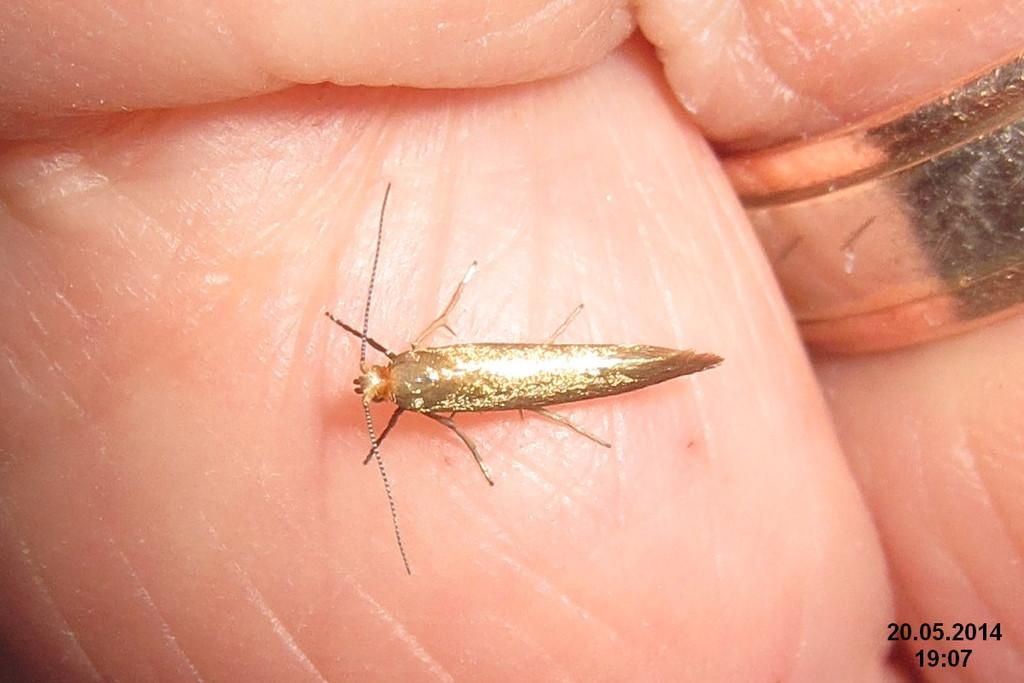What is present on the skin in the image? There is an insect on the skin in the image. What type of jewelry can be seen in the image? There is a ring in the image. Can you tell me the time and date visible in the image? The time and date are visible in the bottom right corner of the image. What type of education is the insect pursuing in the image? There is no indication in the image that the insect is pursuing any education. How does the hand in the image hold the cup? There is no cup present in the image. 